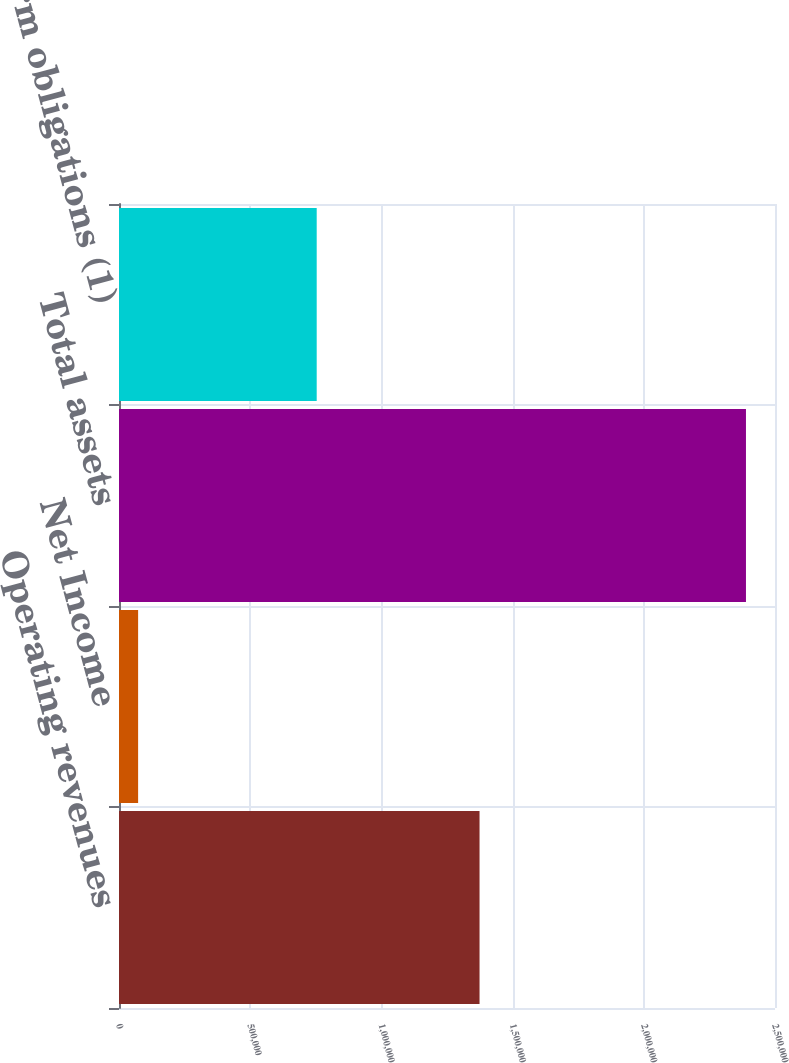Convert chart to OTSL. <chart><loc_0><loc_0><loc_500><loc_500><bar_chart><fcel>Operating revenues<fcel>Net Income<fcel>Total assets<fcel>Long-term obligations (1)<nl><fcel>1.37401e+06<fcel>72853<fcel>2.38936e+06<fcel>753453<nl></chart> 